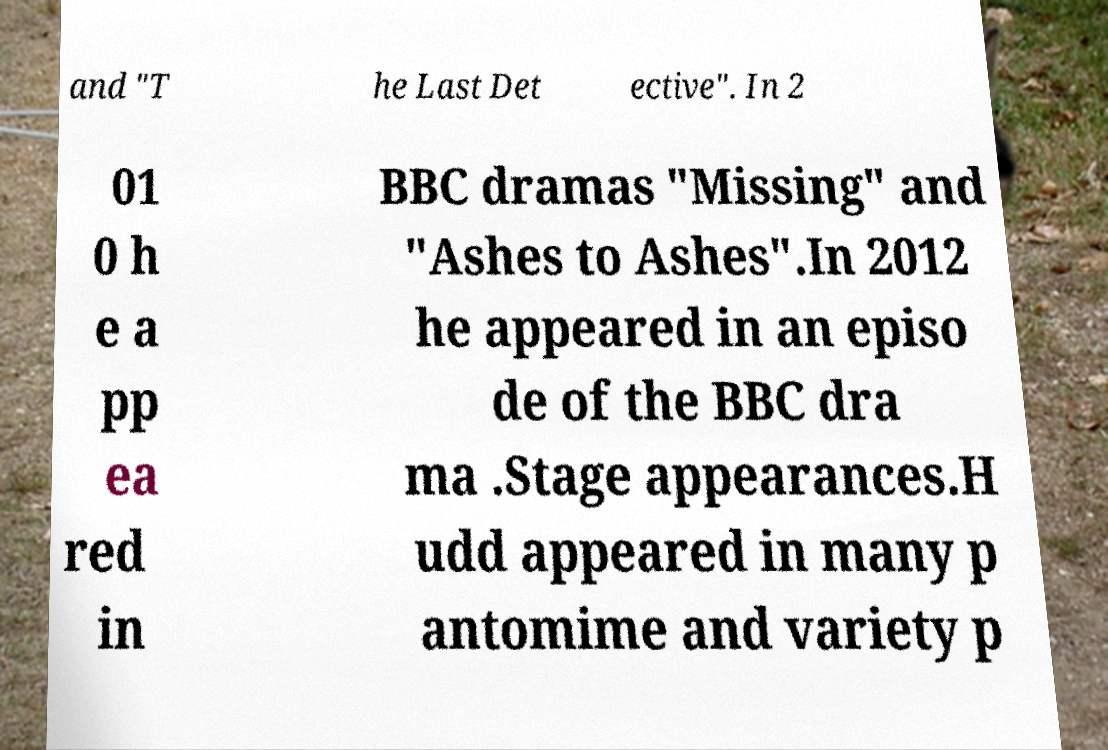Please identify and transcribe the text found in this image. and "T he Last Det ective". In 2 01 0 h e a pp ea red in BBC dramas "Missing" and "Ashes to Ashes".In 2012 he appeared in an episo de of the BBC dra ma .Stage appearances.H udd appeared in many p antomime and variety p 